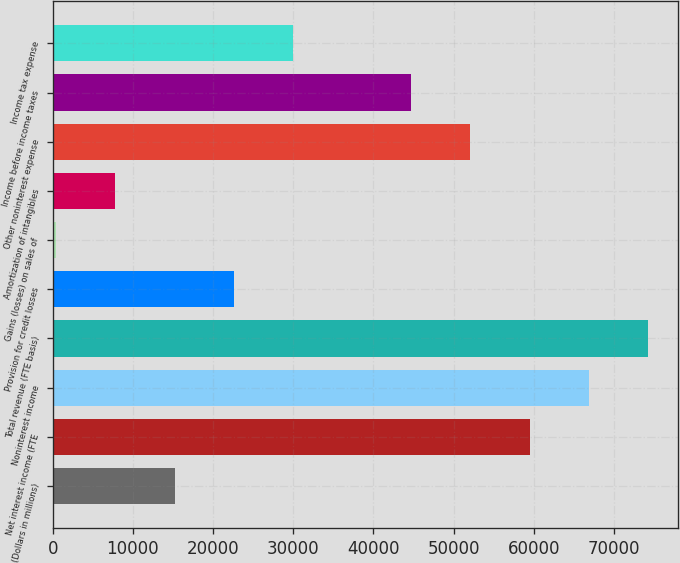Convert chart to OTSL. <chart><loc_0><loc_0><loc_500><loc_500><bar_chart><fcel>(Dollars in millions)<fcel>Net interest income (FTE<fcel>Noninterest income<fcel>Total revenue (FTE basis)<fcel>Provision for credit losses<fcel>Gains (losses) on sales of<fcel>Amortization of intangibles<fcel>Other noninterest expense<fcel>Income before income taxes<fcel>Income tax expense<nl><fcel>15203.8<fcel>59486.2<fcel>66866.6<fcel>74247<fcel>22584.2<fcel>443<fcel>7823.4<fcel>52105.8<fcel>44725.4<fcel>29964.6<nl></chart> 